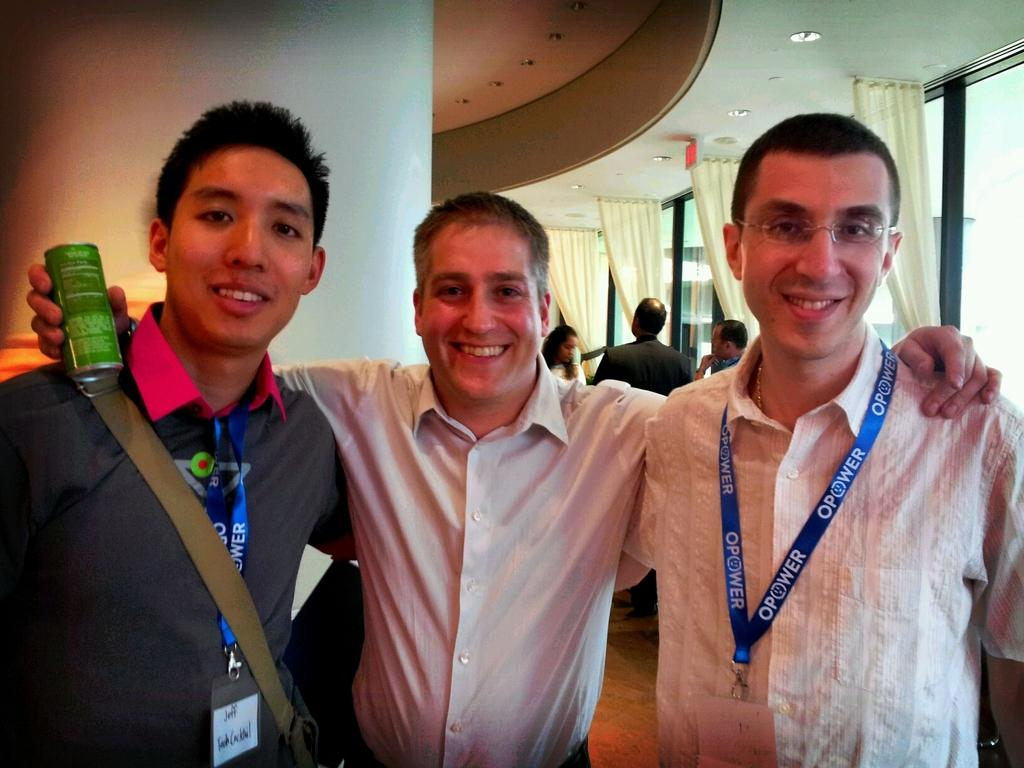Provide a one-sentence caption for the provided image. Three men post for a photo with event lanyards that say Opower. 